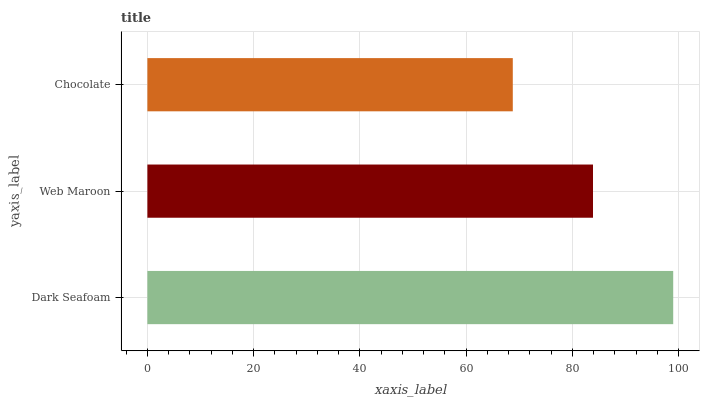Is Chocolate the minimum?
Answer yes or no. Yes. Is Dark Seafoam the maximum?
Answer yes or no. Yes. Is Web Maroon the minimum?
Answer yes or no. No. Is Web Maroon the maximum?
Answer yes or no. No. Is Dark Seafoam greater than Web Maroon?
Answer yes or no. Yes. Is Web Maroon less than Dark Seafoam?
Answer yes or no. Yes. Is Web Maroon greater than Dark Seafoam?
Answer yes or no. No. Is Dark Seafoam less than Web Maroon?
Answer yes or no. No. Is Web Maroon the high median?
Answer yes or no. Yes. Is Web Maroon the low median?
Answer yes or no. Yes. Is Chocolate the high median?
Answer yes or no. No. Is Chocolate the low median?
Answer yes or no. No. 